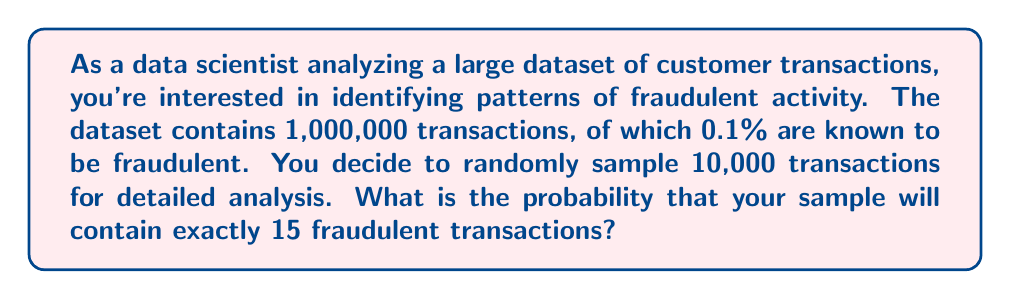Teach me how to tackle this problem. To solve this problem, we can use the binomial probability distribution, as we are dealing with a fixed number of independent trials (the sample) with two possible outcomes for each trial (fraudulent or not fraudulent).

Let's break it down step by step:

1. Identify the parameters:
   - $n$ = sample size = 10,000
   - $p$ = probability of a transaction being fraudulent = 0.001 (0.1%)
   - $k$ = number of fraudulent transactions we're looking for = 15

2. The probability mass function for the binomial distribution is:

   $$P(X = k) = \binom{n}{k} p^k (1-p)^{n-k}$$

3. Calculate the binomial coefficient:

   $$\binom{n}{k} = \binom{10000}{15} = \frac{10000!}{15!(10000-15)!}$$

4. Substitute the values into the formula:

   $$P(X = 15) = \binom{10000}{15} (0.001)^{15} (1-0.001)^{10000-15}$$

5. Compute the result:
   - The binomial coefficient $\binom{10000}{15}$ is a very large number
   - $(0.001)^{15}$ is a very small number
   - $(0.999)^{9985}$ is close to 1

6. Using a calculator or programming language to compute this precisely, we get:

   $$P(X = 15) \approx 0.0516$$

This means there is approximately a 5.16% chance of finding exactly 15 fraudulent transactions in the sample of 10,000.
Answer: The probability of finding exactly 15 fraudulent transactions in a random sample of 10,000 transactions is approximately 0.0516 or 5.16%. 